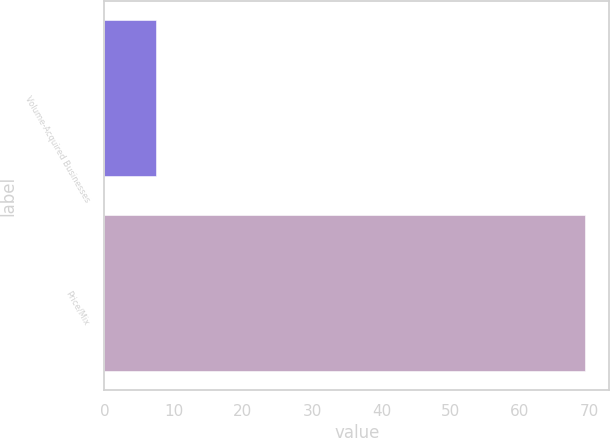<chart> <loc_0><loc_0><loc_500><loc_500><bar_chart><fcel>Volume-Acquired Businesses<fcel>Price/Mix<nl><fcel>7.4<fcel>69.4<nl></chart> 